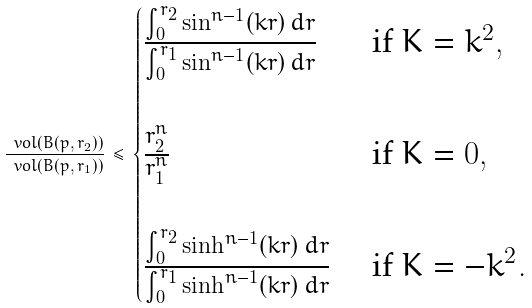<formula> <loc_0><loc_0><loc_500><loc_500>\frac { \ v o l ( B ( p , r _ { 2 } ) ) } { \ v o l ( B ( p , r _ { 1 } ) ) } \, \leq \, \begin{cases} \frac { \int _ { 0 } ^ { r _ { 2 } } \sin ^ { n - 1 } ( k r ) \, d r } { \int _ { 0 } ^ { r _ { 1 } } \sin ^ { n - 1 } ( k r ) \, d r } & \text { if } K = k ^ { 2 } , \\ \\ \frac { r _ { 2 } ^ { n } } { r _ { 1 } ^ { n } } & \text { if } K = 0 , \\ \\ \frac { \int _ { 0 } ^ { r _ { 2 } } \sinh ^ { n - 1 } ( k r ) \, d r } { \int _ { 0 } ^ { r _ { 1 } } \sinh ^ { n - 1 } ( k r ) \, d r } & \text { if } K = - k ^ { 2 } . \end{cases}</formula> 